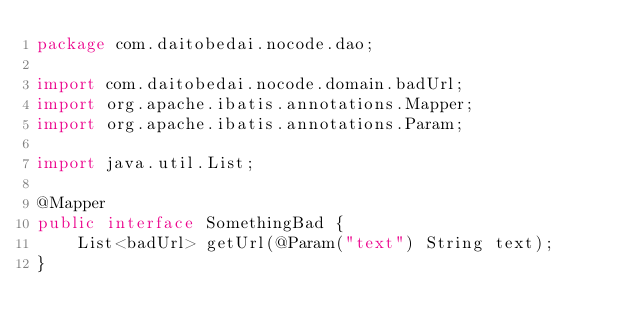<code> <loc_0><loc_0><loc_500><loc_500><_Java_>package com.daitobedai.nocode.dao;

import com.daitobedai.nocode.domain.badUrl;
import org.apache.ibatis.annotations.Mapper;
import org.apache.ibatis.annotations.Param;

import java.util.List;

@Mapper
public interface SomethingBad {
    List<badUrl> getUrl(@Param("text") String text);
}
</code> 